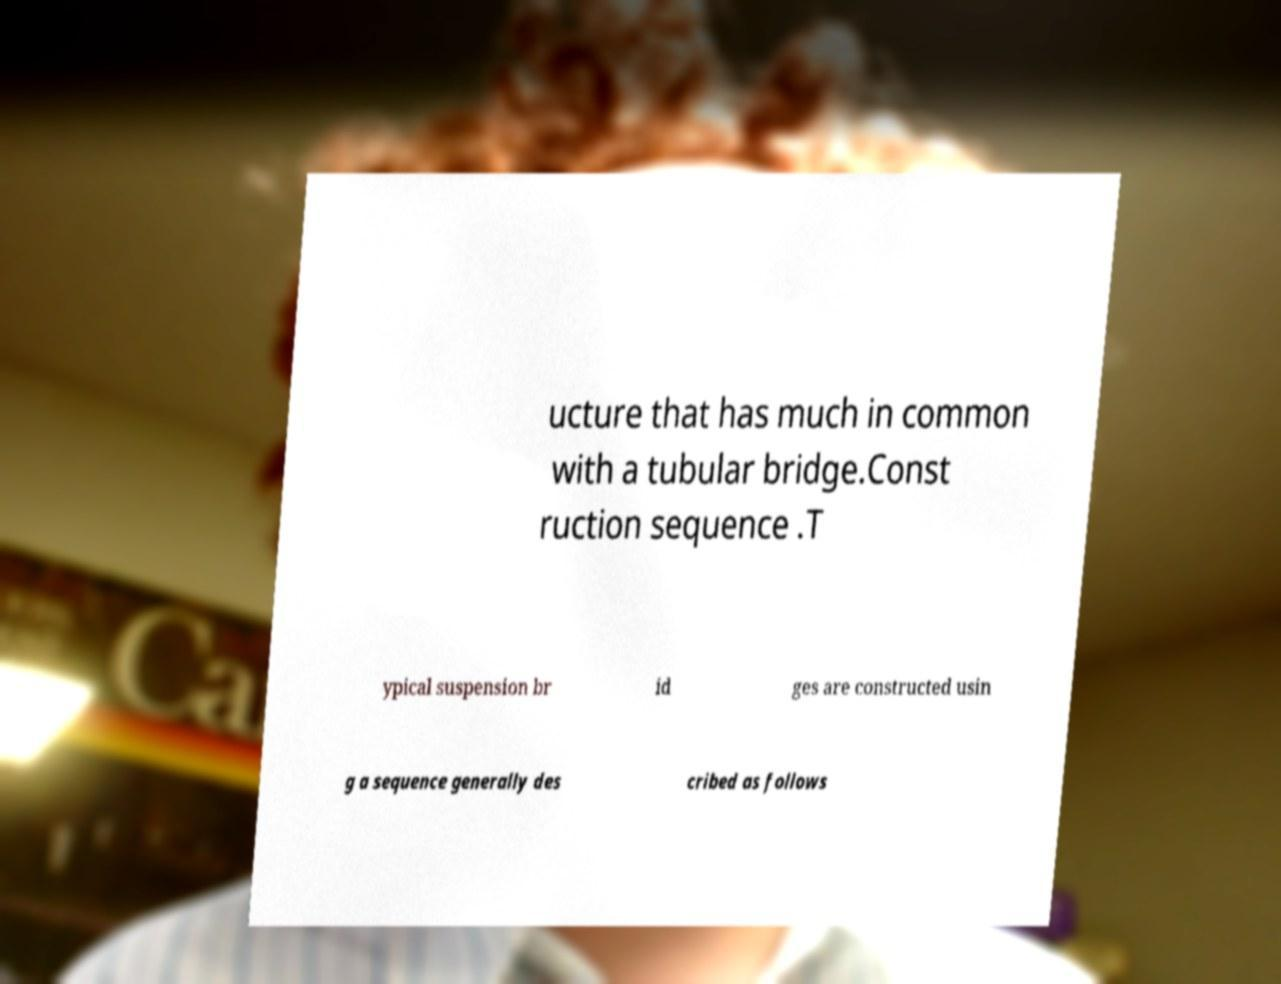Please read and relay the text visible in this image. What does it say? ucture that has much in common with a tubular bridge.Const ruction sequence .T ypical suspension br id ges are constructed usin g a sequence generally des cribed as follows 